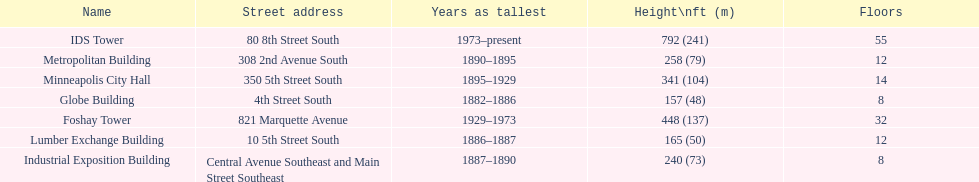How many buildings on the list are taller than 200 feet? 5. 